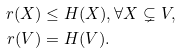<formula> <loc_0><loc_0><loc_500><loc_500>r ( X ) & \leq H ( X ) , \forall X \subsetneq V , \\ r ( V ) & = H ( V ) .</formula> 